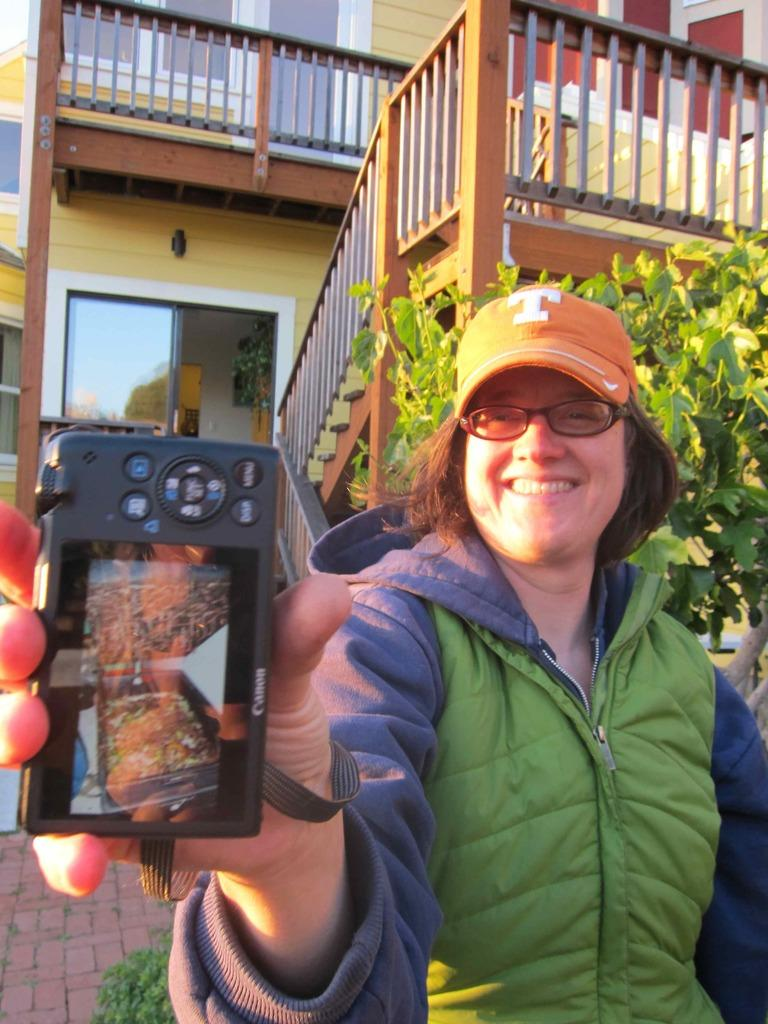Who is the main subject in the image? There is a woman in the image. What is the woman doing in the image? The woman is standing and holding a camera in her hand. What can be seen in the background of the image? There is a building in the background of the image. What type of quince is the woman eating in the image? There is no quince present in the image; the woman is holding a camera. What is the limit of the woman's ability to take photographs in the image? The facts provided do not mention any limitations on the woman's ability to take photographs. 